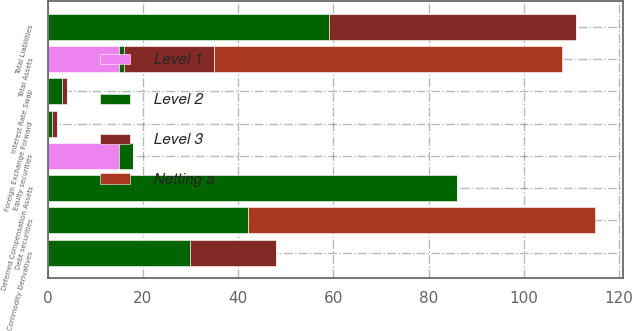Convert chart to OTSL. <chart><loc_0><loc_0><loc_500><loc_500><stacked_bar_chart><ecel><fcel>Commodity Derivatives<fcel>Foreign Exchange Forward<fcel>Debt securities<fcel>Equity securities<fcel>Deferred Compensation Assets<fcel>Total Assets<fcel>Interest Rate Swap<fcel>Total Liabilities<nl><fcel>Level 1<fcel>0<fcel>0<fcel>0<fcel>15<fcel>0<fcel>15<fcel>0<fcel>0<nl><fcel>Level 2<fcel>30<fcel>1<fcel>42<fcel>3<fcel>86<fcel>1<fcel>3<fcel>59<nl><fcel>Netting a<fcel>0<fcel>0<fcel>73<fcel>0<fcel>0<fcel>73<fcel>0<fcel>0<nl><fcel>Level 3<fcel>18<fcel>1<fcel>0<fcel>0<fcel>0<fcel>19<fcel>1<fcel>52<nl></chart> 